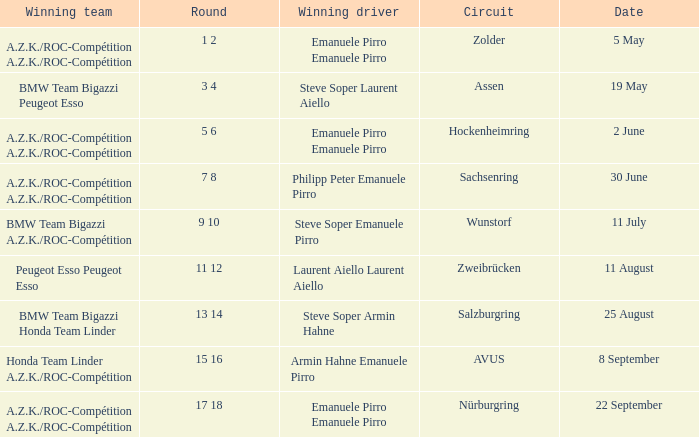Who is the winning driver of the race on 5 May? Emanuele Pirro Emanuele Pirro. 